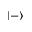Convert formula to latex. <formula><loc_0><loc_0><loc_500><loc_500>| - \rangle</formula> 